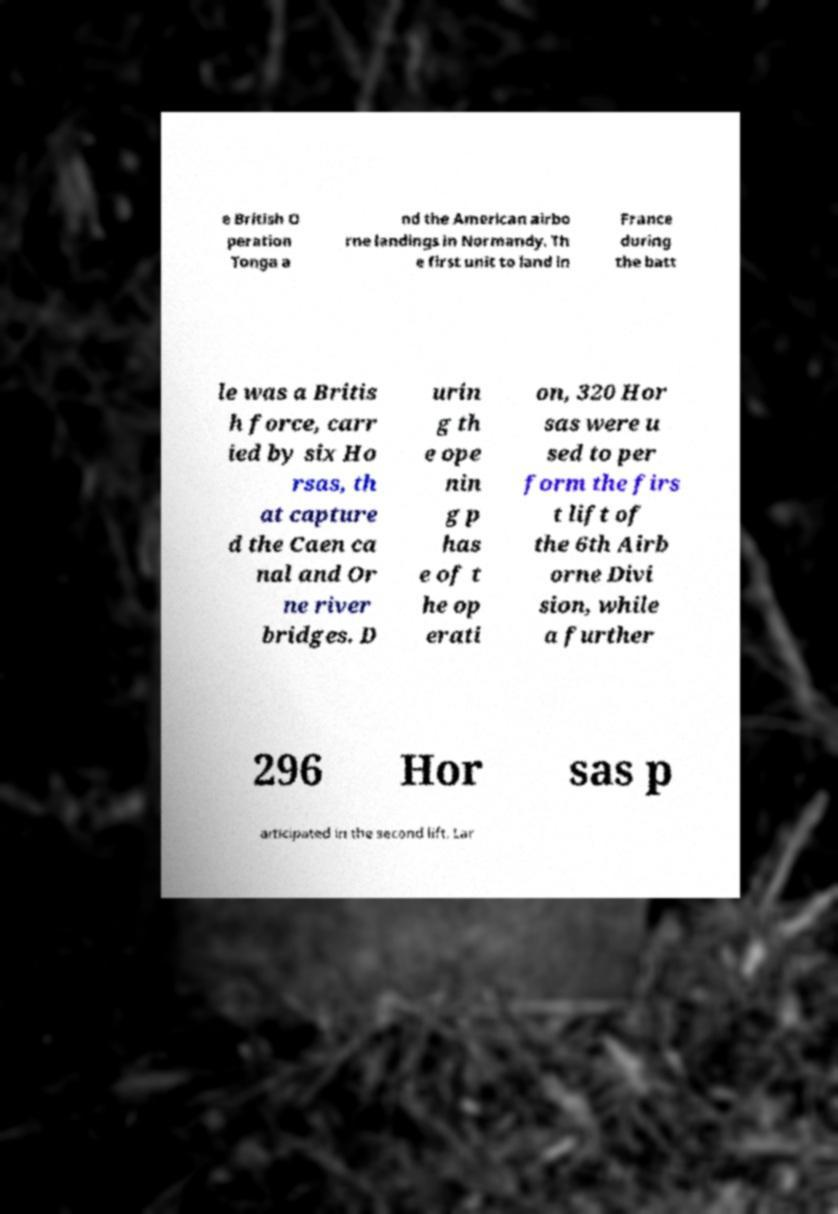For documentation purposes, I need the text within this image transcribed. Could you provide that? e British O peration Tonga a nd the American airbo rne landings in Normandy. Th e first unit to land in France during the batt le was a Britis h force, carr ied by six Ho rsas, th at capture d the Caen ca nal and Or ne river bridges. D urin g th e ope nin g p has e of t he op erati on, 320 Hor sas were u sed to per form the firs t lift of the 6th Airb orne Divi sion, while a further 296 Hor sas p articipated in the second lift. Lar 